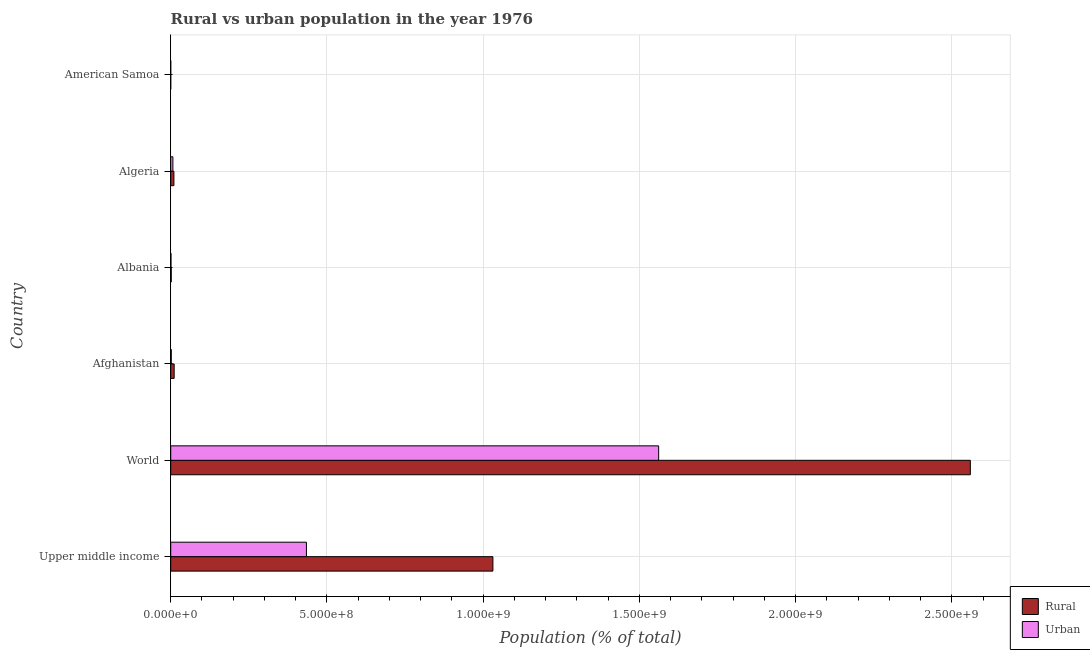How many groups of bars are there?
Give a very brief answer. 6. Are the number of bars on each tick of the Y-axis equal?
Make the answer very short. Yes. How many bars are there on the 4th tick from the top?
Provide a succinct answer. 2. How many bars are there on the 2nd tick from the bottom?
Your answer should be compact. 2. What is the label of the 2nd group of bars from the top?
Provide a succinct answer. Algeria. What is the rural population density in World?
Make the answer very short. 2.56e+09. Across all countries, what is the maximum rural population density?
Offer a very short reply. 2.56e+09. Across all countries, what is the minimum rural population density?
Make the answer very short. 8267. In which country was the rural population density minimum?
Your answer should be very brief. American Samoa. What is the total rural population density in the graph?
Offer a terse response. 3.61e+09. What is the difference between the urban population density in Algeria and that in World?
Your answer should be compact. -1.55e+09. What is the difference between the rural population density in Albania and the urban population density in Algeria?
Your response must be concise. -5.31e+06. What is the average urban population density per country?
Your response must be concise. 3.34e+08. What is the difference between the rural population density and urban population density in Albania?
Provide a short and direct response. 8.40e+05. What is the ratio of the rural population density in American Samoa to that in Upper middle income?
Provide a succinct answer. 0. Is the rural population density in Algeria less than that in Upper middle income?
Make the answer very short. Yes. What is the difference between the highest and the second highest rural population density?
Provide a succinct answer. 1.53e+09. What is the difference between the highest and the lowest rural population density?
Give a very brief answer. 2.56e+09. In how many countries, is the urban population density greater than the average urban population density taken over all countries?
Provide a succinct answer. 2. Is the sum of the rural population density in Albania and Upper middle income greater than the maximum urban population density across all countries?
Make the answer very short. No. What does the 1st bar from the top in Albania represents?
Offer a very short reply. Urban. What does the 2nd bar from the bottom in World represents?
Your answer should be compact. Urban. Are all the bars in the graph horizontal?
Your answer should be compact. Yes. Are the values on the major ticks of X-axis written in scientific E-notation?
Provide a succinct answer. Yes. Does the graph contain any zero values?
Give a very brief answer. No. Does the graph contain grids?
Give a very brief answer. Yes. Where does the legend appear in the graph?
Your answer should be compact. Bottom right. What is the title of the graph?
Offer a very short reply. Rural vs urban population in the year 1976. Does "Enforce a contract" appear as one of the legend labels in the graph?
Offer a very short reply. No. What is the label or title of the X-axis?
Ensure brevity in your answer.  Population (% of total). What is the Population (% of total) in Rural in Upper middle income?
Offer a very short reply. 1.03e+09. What is the Population (% of total) of Urban in Upper middle income?
Give a very brief answer. 4.34e+08. What is the Population (% of total) of Rural in World?
Make the answer very short. 2.56e+09. What is the Population (% of total) in Urban in World?
Give a very brief answer. 1.56e+09. What is the Population (% of total) of Rural in Afghanistan?
Make the answer very short. 1.10e+07. What is the Population (% of total) of Urban in Afghanistan?
Provide a short and direct response. 1.80e+06. What is the Population (% of total) of Rural in Albania?
Provide a succinct answer. 1.65e+06. What is the Population (% of total) of Urban in Albania?
Keep it short and to the point. 8.09e+05. What is the Population (% of total) of Rural in Algeria?
Your answer should be very brief. 1.02e+07. What is the Population (% of total) of Urban in Algeria?
Your answer should be very brief. 6.96e+06. What is the Population (% of total) in Rural in American Samoa?
Make the answer very short. 8267. What is the Population (% of total) of Urban in American Samoa?
Keep it short and to the point. 2.21e+04. Across all countries, what is the maximum Population (% of total) of Rural?
Provide a short and direct response. 2.56e+09. Across all countries, what is the maximum Population (% of total) of Urban?
Make the answer very short. 1.56e+09. Across all countries, what is the minimum Population (% of total) of Rural?
Your response must be concise. 8267. Across all countries, what is the minimum Population (% of total) of Urban?
Offer a very short reply. 2.21e+04. What is the total Population (% of total) of Rural in the graph?
Offer a very short reply. 3.61e+09. What is the total Population (% of total) in Urban in the graph?
Offer a very short reply. 2.01e+09. What is the difference between the Population (% of total) of Rural in Upper middle income and that in World?
Provide a succinct answer. -1.53e+09. What is the difference between the Population (% of total) of Urban in Upper middle income and that in World?
Ensure brevity in your answer.  -1.13e+09. What is the difference between the Population (% of total) in Rural in Upper middle income and that in Afghanistan?
Offer a terse response. 1.02e+09. What is the difference between the Population (% of total) of Urban in Upper middle income and that in Afghanistan?
Your response must be concise. 4.33e+08. What is the difference between the Population (% of total) in Rural in Upper middle income and that in Albania?
Your response must be concise. 1.03e+09. What is the difference between the Population (% of total) of Urban in Upper middle income and that in Albania?
Give a very brief answer. 4.34e+08. What is the difference between the Population (% of total) of Rural in Upper middle income and that in Algeria?
Your response must be concise. 1.02e+09. What is the difference between the Population (% of total) of Urban in Upper middle income and that in Algeria?
Provide a succinct answer. 4.27e+08. What is the difference between the Population (% of total) of Rural in Upper middle income and that in American Samoa?
Ensure brevity in your answer.  1.03e+09. What is the difference between the Population (% of total) in Urban in Upper middle income and that in American Samoa?
Offer a terse response. 4.34e+08. What is the difference between the Population (% of total) of Rural in World and that in Afghanistan?
Offer a terse response. 2.55e+09. What is the difference between the Population (% of total) in Urban in World and that in Afghanistan?
Offer a terse response. 1.56e+09. What is the difference between the Population (% of total) of Rural in World and that in Albania?
Your answer should be compact. 2.56e+09. What is the difference between the Population (% of total) in Urban in World and that in Albania?
Offer a terse response. 1.56e+09. What is the difference between the Population (% of total) in Rural in World and that in Algeria?
Give a very brief answer. 2.55e+09. What is the difference between the Population (% of total) in Urban in World and that in Algeria?
Provide a succinct answer. 1.55e+09. What is the difference between the Population (% of total) of Rural in World and that in American Samoa?
Offer a very short reply. 2.56e+09. What is the difference between the Population (% of total) in Urban in World and that in American Samoa?
Ensure brevity in your answer.  1.56e+09. What is the difference between the Population (% of total) in Rural in Afghanistan and that in Albania?
Give a very brief answer. 9.38e+06. What is the difference between the Population (% of total) of Urban in Afghanistan and that in Albania?
Make the answer very short. 9.91e+05. What is the difference between the Population (% of total) in Rural in Afghanistan and that in Algeria?
Give a very brief answer. 8.03e+05. What is the difference between the Population (% of total) in Urban in Afghanistan and that in Algeria?
Keep it short and to the point. -5.16e+06. What is the difference between the Population (% of total) of Rural in Afghanistan and that in American Samoa?
Offer a terse response. 1.10e+07. What is the difference between the Population (% of total) in Urban in Afghanistan and that in American Samoa?
Ensure brevity in your answer.  1.78e+06. What is the difference between the Population (% of total) of Rural in Albania and that in Algeria?
Offer a very short reply. -8.58e+06. What is the difference between the Population (% of total) in Urban in Albania and that in Algeria?
Keep it short and to the point. -6.15e+06. What is the difference between the Population (% of total) of Rural in Albania and that in American Samoa?
Keep it short and to the point. 1.64e+06. What is the difference between the Population (% of total) of Urban in Albania and that in American Samoa?
Make the answer very short. 7.87e+05. What is the difference between the Population (% of total) of Rural in Algeria and that in American Samoa?
Offer a terse response. 1.02e+07. What is the difference between the Population (% of total) of Urban in Algeria and that in American Samoa?
Your answer should be very brief. 6.94e+06. What is the difference between the Population (% of total) in Rural in Upper middle income and the Population (% of total) in Urban in World?
Make the answer very short. -5.30e+08. What is the difference between the Population (% of total) in Rural in Upper middle income and the Population (% of total) in Urban in Afghanistan?
Your response must be concise. 1.03e+09. What is the difference between the Population (% of total) of Rural in Upper middle income and the Population (% of total) of Urban in Albania?
Give a very brief answer. 1.03e+09. What is the difference between the Population (% of total) of Rural in Upper middle income and the Population (% of total) of Urban in Algeria?
Give a very brief answer. 1.02e+09. What is the difference between the Population (% of total) in Rural in Upper middle income and the Population (% of total) in Urban in American Samoa?
Make the answer very short. 1.03e+09. What is the difference between the Population (% of total) in Rural in World and the Population (% of total) in Urban in Afghanistan?
Your answer should be very brief. 2.56e+09. What is the difference between the Population (% of total) in Rural in World and the Population (% of total) in Urban in Albania?
Offer a terse response. 2.56e+09. What is the difference between the Population (% of total) in Rural in World and the Population (% of total) in Urban in Algeria?
Your answer should be very brief. 2.55e+09. What is the difference between the Population (% of total) of Rural in World and the Population (% of total) of Urban in American Samoa?
Give a very brief answer. 2.56e+09. What is the difference between the Population (% of total) of Rural in Afghanistan and the Population (% of total) of Urban in Albania?
Your answer should be compact. 1.02e+07. What is the difference between the Population (% of total) in Rural in Afghanistan and the Population (% of total) in Urban in Algeria?
Provide a succinct answer. 4.07e+06. What is the difference between the Population (% of total) of Rural in Afghanistan and the Population (% of total) of Urban in American Samoa?
Offer a terse response. 1.10e+07. What is the difference between the Population (% of total) of Rural in Albania and the Population (% of total) of Urban in Algeria?
Provide a short and direct response. -5.31e+06. What is the difference between the Population (% of total) in Rural in Albania and the Population (% of total) in Urban in American Samoa?
Provide a succinct answer. 1.63e+06. What is the difference between the Population (% of total) in Rural in Algeria and the Population (% of total) in Urban in American Samoa?
Your response must be concise. 1.02e+07. What is the average Population (% of total) in Rural per country?
Ensure brevity in your answer.  6.02e+08. What is the average Population (% of total) of Urban per country?
Your answer should be compact. 3.34e+08. What is the difference between the Population (% of total) in Rural and Population (% of total) in Urban in Upper middle income?
Offer a very short reply. 5.97e+08. What is the difference between the Population (% of total) of Rural and Population (% of total) of Urban in World?
Your answer should be compact. 9.98e+08. What is the difference between the Population (% of total) in Rural and Population (% of total) in Urban in Afghanistan?
Offer a terse response. 9.23e+06. What is the difference between the Population (% of total) in Rural and Population (% of total) in Urban in Albania?
Ensure brevity in your answer.  8.40e+05. What is the difference between the Population (% of total) of Rural and Population (% of total) of Urban in Algeria?
Provide a succinct answer. 3.27e+06. What is the difference between the Population (% of total) of Rural and Population (% of total) of Urban in American Samoa?
Your answer should be compact. -1.38e+04. What is the ratio of the Population (% of total) of Rural in Upper middle income to that in World?
Your response must be concise. 0.4. What is the ratio of the Population (% of total) of Urban in Upper middle income to that in World?
Your response must be concise. 0.28. What is the ratio of the Population (% of total) in Rural in Upper middle income to that in Afghanistan?
Offer a terse response. 93.48. What is the ratio of the Population (% of total) of Urban in Upper middle income to that in Afghanistan?
Give a very brief answer. 241.28. What is the ratio of the Population (% of total) in Rural in Upper middle income to that in Albania?
Your response must be concise. 625.15. What is the ratio of the Population (% of total) of Urban in Upper middle income to that in Albania?
Your answer should be very brief. 536.85. What is the ratio of the Population (% of total) of Rural in Upper middle income to that in Algeria?
Make the answer very short. 100.81. What is the ratio of the Population (% of total) of Urban in Upper middle income to that in Algeria?
Provide a succinct answer. 62.39. What is the ratio of the Population (% of total) of Rural in Upper middle income to that in American Samoa?
Your response must be concise. 1.25e+05. What is the ratio of the Population (% of total) in Urban in Upper middle income to that in American Samoa?
Offer a very short reply. 1.97e+04. What is the ratio of the Population (% of total) of Rural in World to that in Afghanistan?
Make the answer very short. 231.99. What is the ratio of the Population (% of total) of Urban in World to that in Afghanistan?
Offer a terse response. 867.52. What is the ratio of the Population (% of total) in Rural in World to that in Albania?
Make the answer very short. 1551.5. What is the ratio of the Population (% of total) in Urban in World to that in Albania?
Keep it short and to the point. 1930.21. What is the ratio of the Population (% of total) in Rural in World to that in Algeria?
Your answer should be compact. 250.19. What is the ratio of the Population (% of total) in Urban in World to that in Algeria?
Keep it short and to the point. 224.32. What is the ratio of the Population (% of total) in Rural in World to that in American Samoa?
Your answer should be very brief. 3.10e+05. What is the ratio of the Population (% of total) of Urban in World to that in American Samoa?
Offer a terse response. 7.08e+04. What is the ratio of the Population (% of total) of Rural in Afghanistan to that in Albania?
Keep it short and to the point. 6.69. What is the ratio of the Population (% of total) of Urban in Afghanistan to that in Albania?
Provide a succinct answer. 2.23. What is the ratio of the Population (% of total) of Rural in Afghanistan to that in Algeria?
Offer a terse response. 1.08. What is the ratio of the Population (% of total) of Urban in Afghanistan to that in Algeria?
Provide a short and direct response. 0.26. What is the ratio of the Population (% of total) of Rural in Afghanistan to that in American Samoa?
Give a very brief answer. 1334.37. What is the ratio of the Population (% of total) in Urban in Afghanistan to that in American Samoa?
Give a very brief answer. 81.61. What is the ratio of the Population (% of total) in Rural in Albania to that in Algeria?
Your answer should be compact. 0.16. What is the ratio of the Population (% of total) in Urban in Albania to that in Algeria?
Provide a short and direct response. 0.12. What is the ratio of the Population (% of total) in Rural in Albania to that in American Samoa?
Provide a short and direct response. 199.53. What is the ratio of the Population (% of total) of Urban in Albania to that in American Samoa?
Your answer should be very brief. 36.68. What is the ratio of the Population (% of total) in Rural in Algeria to that in American Samoa?
Your answer should be compact. 1237.29. What is the ratio of the Population (% of total) in Urban in Algeria to that in American Samoa?
Make the answer very short. 315.6. What is the difference between the highest and the second highest Population (% of total) in Rural?
Offer a very short reply. 1.53e+09. What is the difference between the highest and the second highest Population (% of total) of Urban?
Give a very brief answer. 1.13e+09. What is the difference between the highest and the lowest Population (% of total) in Rural?
Offer a very short reply. 2.56e+09. What is the difference between the highest and the lowest Population (% of total) of Urban?
Keep it short and to the point. 1.56e+09. 